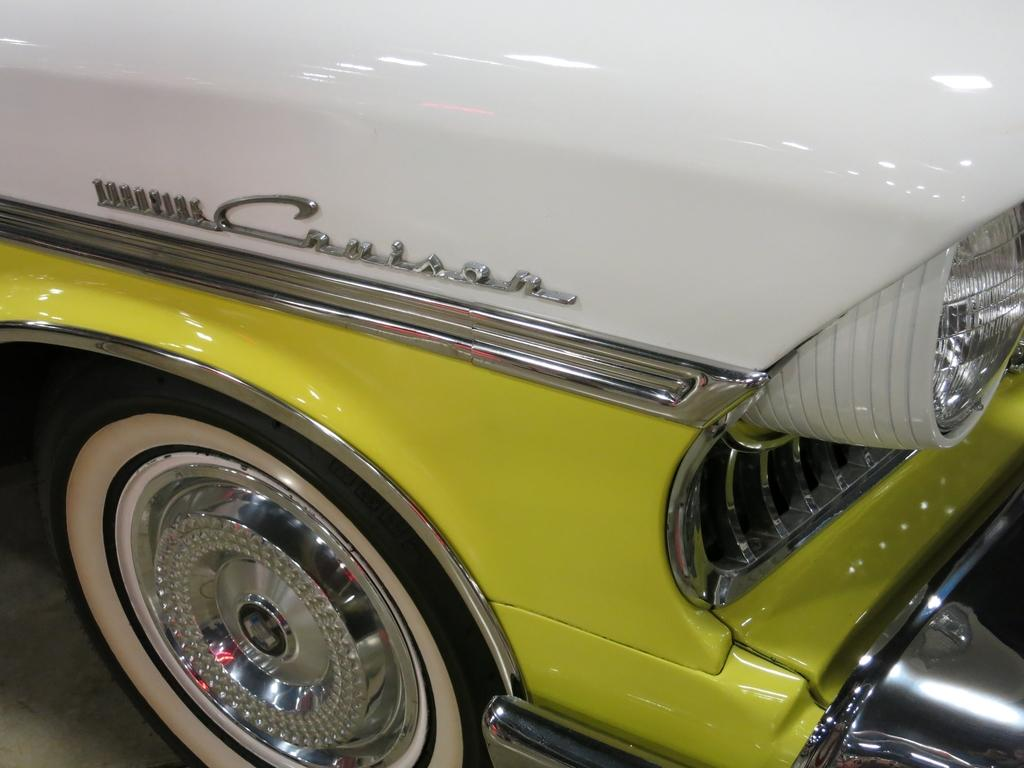What is the main subject of the image? There is a vehicle in the image. Where is the vehicle located? The vehicle is on the road. What type of note can be seen attached to the vehicle in the image? There is no note attached to the vehicle in the image. What kind of support is the vehicle using to stay upright in the image? The vehicle is already on the road, so it does not require any additional support to stay upright. 